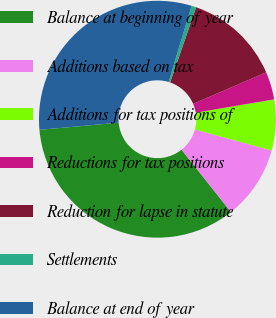<chart> <loc_0><loc_0><loc_500><loc_500><pie_chart><fcel>Balance at beginning of year<fcel>Additions based on tax<fcel>Additions for tax positions of<fcel>Reductions for tax positions<fcel>Reduction for lapse in statute<fcel>Settlements<fcel>Balance at end of year<nl><fcel>34.24%<fcel>10.08%<fcel>6.94%<fcel>3.79%<fcel>13.23%<fcel>0.64%<fcel>31.09%<nl></chart> 